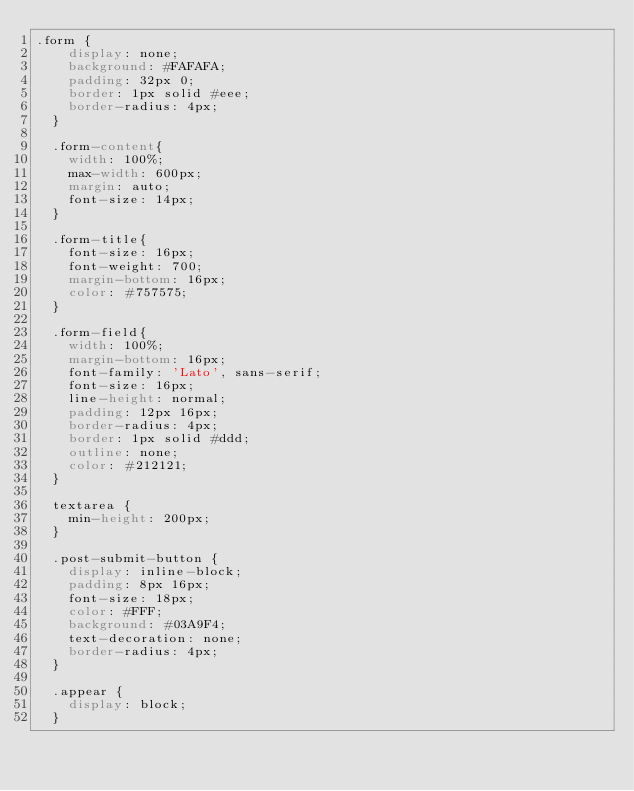Convert code to text. <code><loc_0><loc_0><loc_500><loc_500><_CSS_>.form {
    display: none;
    background: #FAFAFA;
    padding: 32px 0;
    border: 1px solid #eee;
    border-radius: 4px;
  }
  
  .form-content{
    width: 100%;
    max-width: 600px;
    margin: auto;
    font-size: 14px;
  }
  
  .form-title{
    font-size: 16px;
    font-weight: 700;
    margin-bottom: 16px;
    color: #757575;
  }
  
  .form-field{
    width: 100%;
    margin-bottom: 16px;
    font-family: 'Lato', sans-serif;
    font-size: 16px;
    line-height: normal;
    padding: 12px 16px;
    border-radius: 4px;
    border: 1px solid #ddd;
    outline: none;
    color: #212121;
  }
  
  textarea {
    min-height: 200px;
  }
  
  .post-submit-button {
    display: inline-block;
    padding: 8px 16px;
    font-size: 18px;
    color: #FFF;
    background: #03A9F4;
    text-decoration: none;
    border-radius: 4px;
  }
  
  .appear {
    display: block;
  }
  </code> 